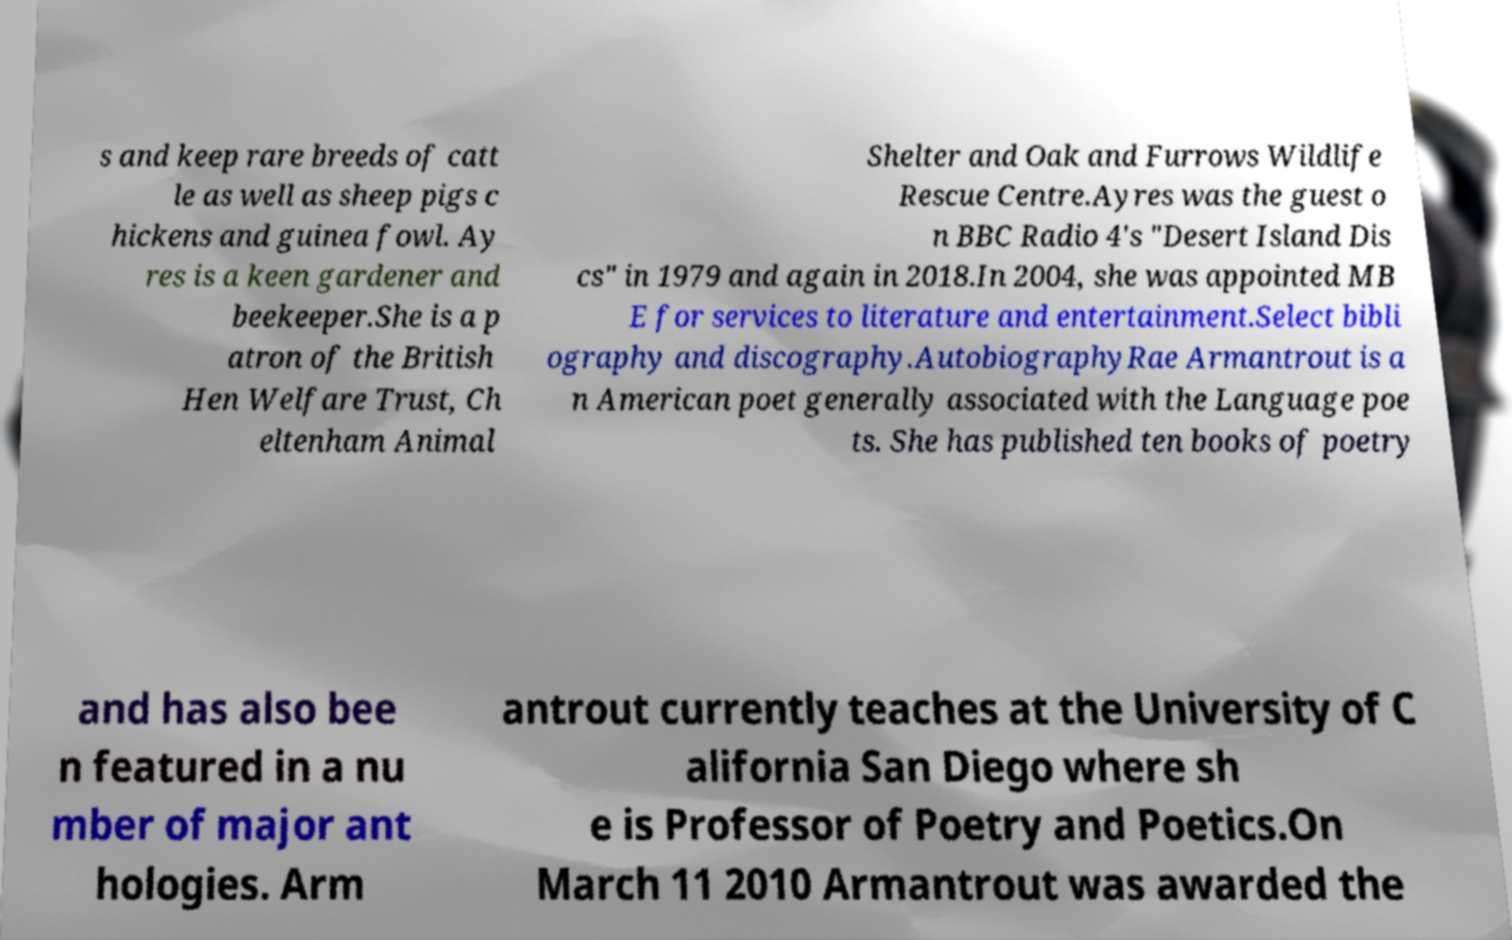Can you accurately transcribe the text from the provided image for me? s and keep rare breeds of catt le as well as sheep pigs c hickens and guinea fowl. Ay res is a keen gardener and beekeeper.She is a p atron of the British Hen Welfare Trust, Ch eltenham Animal Shelter and Oak and Furrows Wildlife Rescue Centre.Ayres was the guest o n BBC Radio 4's "Desert Island Dis cs" in 1979 and again in 2018.In 2004, she was appointed MB E for services to literature and entertainment.Select bibli ography and discography.AutobiographyRae Armantrout is a n American poet generally associated with the Language poe ts. She has published ten books of poetry and has also bee n featured in a nu mber of major ant hologies. Arm antrout currently teaches at the University of C alifornia San Diego where sh e is Professor of Poetry and Poetics.On March 11 2010 Armantrout was awarded the 